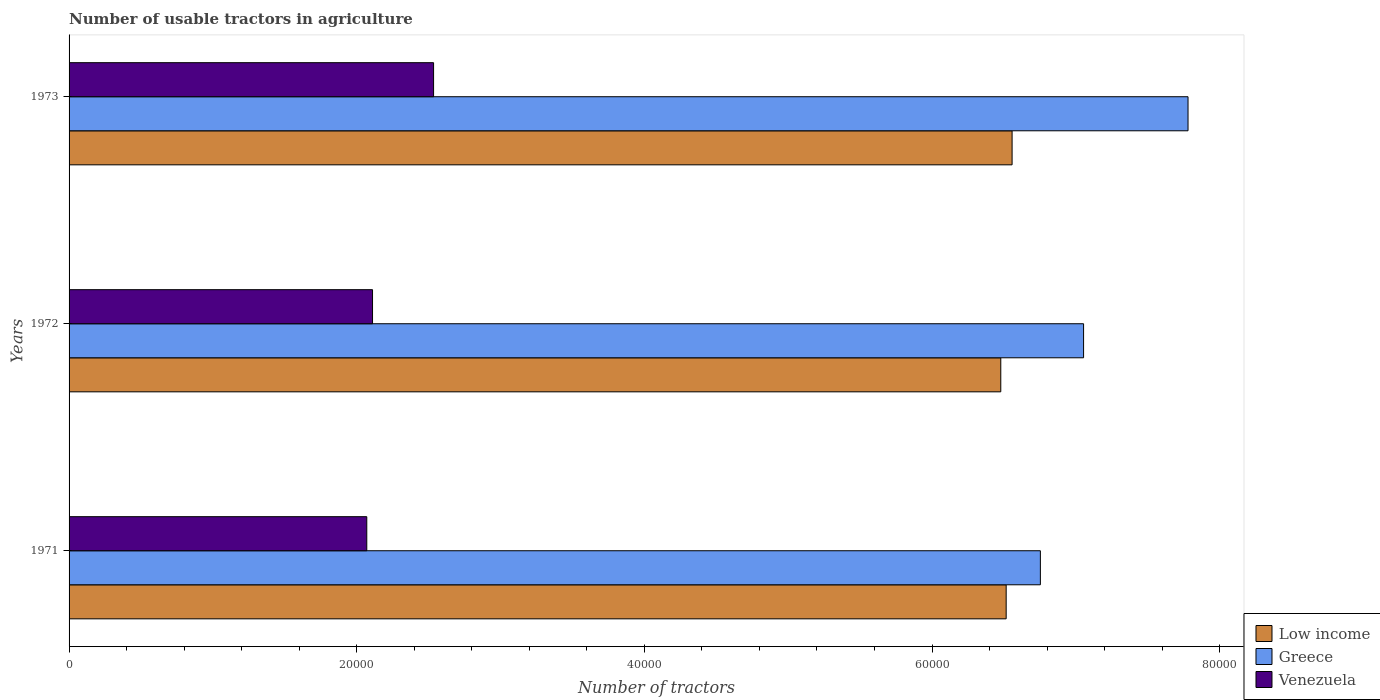How many different coloured bars are there?
Make the answer very short. 3. How many groups of bars are there?
Provide a succinct answer. 3. How many bars are there on the 3rd tick from the top?
Offer a terse response. 3. How many bars are there on the 2nd tick from the bottom?
Your answer should be compact. 3. In how many cases, is the number of bars for a given year not equal to the number of legend labels?
Make the answer very short. 0. What is the number of usable tractors in agriculture in Low income in 1972?
Offer a terse response. 6.48e+04. Across all years, what is the maximum number of usable tractors in agriculture in Greece?
Offer a very short reply. 7.78e+04. Across all years, what is the minimum number of usable tractors in agriculture in Low income?
Your answer should be compact. 6.48e+04. What is the total number of usable tractors in agriculture in Low income in the graph?
Offer a very short reply. 1.96e+05. What is the difference between the number of usable tractors in agriculture in Venezuela in 1971 and that in 1972?
Make the answer very short. -400. What is the difference between the number of usable tractors in agriculture in Venezuela in 1973 and the number of usable tractors in agriculture in Greece in 1972?
Keep it short and to the point. -4.52e+04. What is the average number of usable tractors in agriculture in Venezuela per year?
Provide a short and direct response. 2.24e+04. In the year 1971, what is the difference between the number of usable tractors in agriculture in Venezuela and number of usable tractors in agriculture in Greece?
Offer a very short reply. -4.68e+04. What is the ratio of the number of usable tractors in agriculture in Greece in 1972 to that in 1973?
Ensure brevity in your answer.  0.91. Is the number of usable tractors in agriculture in Greece in 1971 less than that in 1973?
Your answer should be very brief. Yes. Is the difference between the number of usable tractors in agriculture in Venezuela in 1971 and 1972 greater than the difference between the number of usable tractors in agriculture in Greece in 1971 and 1972?
Your answer should be compact. Yes. What is the difference between the highest and the second highest number of usable tractors in agriculture in Greece?
Keep it short and to the point. 7262. What is the difference between the highest and the lowest number of usable tractors in agriculture in Greece?
Ensure brevity in your answer.  1.03e+04. In how many years, is the number of usable tractors in agriculture in Low income greater than the average number of usable tractors in agriculture in Low income taken over all years?
Your response must be concise. 1. What does the 1st bar from the top in 1972 represents?
Ensure brevity in your answer.  Venezuela. What does the 1st bar from the bottom in 1971 represents?
Offer a terse response. Low income. How many bars are there?
Your response must be concise. 9. Are all the bars in the graph horizontal?
Ensure brevity in your answer.  Yes. How many years are there in the graph?
Keep it short and to the point. 3. What is the difference between two consecutive major ticks on the X-axis?
Ensure brevity in your answer.  2.00e+04. Are the values on the major ticks of X-axis written in scientific E-notation?
Give a very brief answer. No. Does the graph contain grids?
Offer a terse response. No. What is the title of the graph?
Your answer should be compact. Number of usable tractors in agriculture. Does "Bulgaria" appear as one of the legend labels in the graph?
Give a very brief answer. No. What is the label or title of the X-axis?
Make the answer very short. Number of tractors. What is the label or title of the Y-axis?
Your answer should be compact. Years. What is the Number of tractors in Low income in 1971?
Provide a succinct answer. 6.52e+04. What is the Number of tractors in Greece in 1971?
Offer a terse response. 6.75e+04. What is the Number of tractors of Venezuela in 1971?
Your answer should be very brief. 2.07e+04. What is the Number of tractors in Low income in 1972?
Your answer should be compact. 6.48e+04. What is the Number of tractors of Greece in 1972?
Give a very brief answer. 7.05e+04. What is the Number of tractors of Venezuela in 1972?
Ensure brevity in your answer.  2.11e+04. What is the Number of tractors in Low income in 1973?
Offer a terse response. 6.56e+04. What is the Number of tractors in Greece in 1973?
Give a very brief answer. 7.78e+04. What is the Number of tractors in Venezuela in 1973?
Provide a succinct answer. 2.53e+04. Across all years, what is the maximum Number of tractors in Low income?
Offer a very short reply. 6.56e+04. Across all years, what is the maximum Number of tractors of Greece?
Provide a short and direct response. 7.78e+04. Across all years, what is the maximum Number of tractors in Venezuela?
Your answer should be very brief. 2.53e+04. Across all years, what is the minimum Number of tractors in Low income?
Keep it short and to the point. 6.48e+04. Across all years, what is the minimum Number of tractors in Greece?
Provide a short and direct response. 6.75e+04. Across all years, what is the minimum Number of tractors in Venezuela?
Keep it short and to the point. 2.07e+04. What is the total Number of tractors in Low income in the graph?
Make the answer very short. 1.96e+05. What is the total Number of tractors of Greece in the graph?
Ensure brevity in your answer.  2.16e+05. What is the total Number of tractors of Venezuela in the graph?
Your answer should be very brief. 6.71e+04. What is the difference between the Number of tractors of Low income in 1971 and that in 1972?
Offer a terse response. 374. What is the difference between the Number of tractors in Greece in 1971 and that in 1972?
Provide a short and direct response. -3004. What is the difference between the Number of tractors in Venezuela in 1971 and that in 1972?
Provide a succinct answer. -400. What is the difference between the Number of tractors of Low income in 1971 and that in 1973?
Offer a very short reply. -412. What is the difference between the Number of tractors in Greece in 1971 and that in 1973?
Offer a terse response. -1.03e+04. What is the difference between the Number of tractors in Venezuela in 1971 and that in 1973?
Give a very brief answer. -4645. What is the difference between the Number of tractors of Low income in 1972 and that in 1973?
Provide a short and direct response. -786. What is the difference between the Number of tractors in Greece in 1972 and that in 1973?
Make the answer very short. -7262. What is the difference between the Number of tractors of Venezuela in 1972 and that in 1973?
Offer a terse response. -4245. What is the difference between the Number of tractors of Low income in 1971 and the Number of tractors of Greece in 1972?
Give a very brief answer. -5383. What is the difference between the Number of tractors of Low income in 1971 and the Number of tractors of Venezuela in 1972?
Your answer should be very brief. 4.41e+04. What is the difference between the Number of tractors in Greece in 1971 and the Number of tractors in Venezuela in 1972?
Your answer should be very brief. 4.64e+04. What is the difference between the Number of tractors in Low income in 1971 and the Number of tractors in Greece in 1973?
Provide a short and direct response. -1.26e+04. What is the difference between the Number of tractors in Low income in 1971 and the Number of tractors in Venezuela in 1973?
Offer a very short reply. 3.98e+04. What is the difference between the Number of tractors in Greece in 1971 and the Number of tractors in Venezuela in 1973?
Keep it short and to the point. 4.22e+04. What is the difference between the Number of tractors in Low income in 1972 and the Number of tractors in Greece in 1973?
Offer a very short reply. -1.30e+04. What is the difference between the Number of tractors in Low income in 1972 and the Number of tractors in Venezuela in 1973?
Ensure brevity in your answer.  3.94e+04. What is the difference between the Number of tractors in Greece in 1972 and the Number of tractors in Venezuela in 1973?
Provide a succinct answer. 4.52e+04. What is the average Number of tractors in Low income per year?
Provide a succinct answer. 6.52e+04. What is the average Number of tractors of Greece per year?
Provide a succinct answer. 7.20e+04. What is the average Number of tractors of Venezuela per year?
Keep it short and to the point. 2.24e+04. In the year 1971, what is the difference between the Number of tractors of Low income and Number of tractors of Greece?
Offer a very short reply. -2379. In the year 1971, what is the difference between the Number of tractors in Low income and Number of tractors in Venezuela?
Keep it short and to the point. 4.45e+04. In the year 1971, what is the difference between the Number of tractors in Greece and Number of tractors in Venezuela?
Your response must be concise. 4.68e+04. In the year 1972, what is the difference between the Number of tractors of Low income and Number of tractors of Greece?
Keep it short and to the point. -5757. In the year 1972, what is the difference between the Number of tractors in Low income and Number of tractors in Venezuela?
Your answer should be compact. 4.37e+04. In the year 1972, what is the difference between the Number of tractors in Greece and Number of tractors in Venezuela?
Your response must be concise. 4.94e+04. In the year 1973, what is the difference between the Number of tractors of Low income and Number of tractors of Greece?
Your response must be concise. -1.22e+04. In the year 1973, what is the difference between the Number of tractors of Low income and Number of tractors of Venezuela?
Offer a very short reply. 4.02e+04. In the year 1973, what is the difference between the Number of tractors in Greece and Number of tractors in Venezuela?
Ensure brevity in your answer.  5.25e+04. What is the ratio of the Number of tractors of Low income in 1971 to that in 1972?
Ensure brevity in your answer.  1.01. What is the ratio of the Number of tractors in Greece in 1971 to that in 1972?
Offer a terse response. 0.96. What is the ratio of the Number of tractors in Venezuela in 1971 to that in 1972?
Offer a terse response. 0.98. What is the ratio of the Number of tractors in Low income in 1971 to that in 1973?
Offer a very short reply. 0.99. What is the ratio of the Number of tractors in Greece in 1971 to that in 1973?
Ensure brevity in your answer.  0.87. What is the ratio of the Number of tractors in Venezuela in 1971 to that in 1973?
Keep it short and to the point. 0.82. What is the ratio of the Number of tractors of Greece in 1972 to that in 1973?
Your answer should be very brief. 0.91. What is the ratio of the Number of tractors of Venezuela in 1972 to that in 1973?
Make the answer very short. 0.83. What is the difference between the highest and the second highest Number of tractors in Low income?
Your answer should be very brief. 412. What is the difference between the highest and the second highest Number of tractors of Greece?
Offer a very short reply. 7262. What is the difference between the highest and the second highest Number of tractors of Venezuela?
Keep it short and to the point. 4245. What is the difference between the highest and the lowest Number of tractors in Low income?
Provide a short and direct response. 786. What is the difference between the highest and the lowest Number of tractors in Greece?
Keep it short and to the point. 1.03e+04. What is the difference between the highest and the lowest Number of tractors in Venezuela?
Ensure brevity in your answer.  4645. 